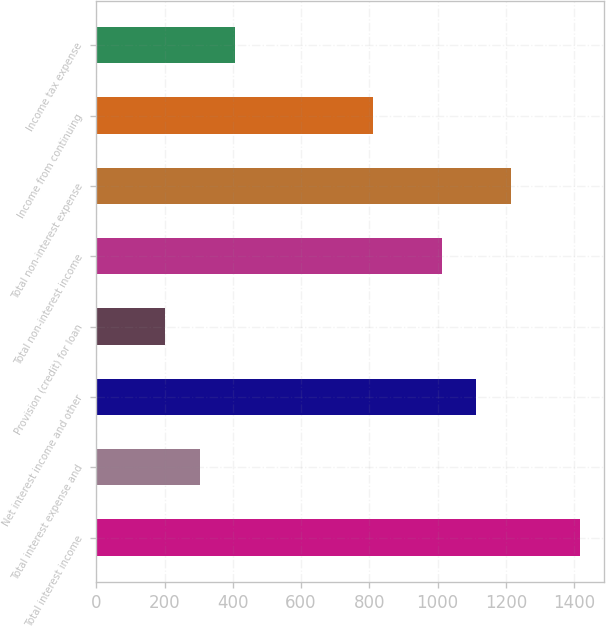Convert chart. <chart><loc_0><loc_0><loc_500><loc_500><bar_chart><fcel>Total interest income<fcel>Total interest expense and<fcel>Net interest income and other<fcel>Provision (credit) for loan<fcel>Total non-interest income<fcel>Total non-interest expense<fcel>Income from continuing<fcel>Income tax expense<nl><fcel>1416.73<fcel>303.79<fcel>1113.21<fcel>202.61<fcel>1012.04<fcel>1214.38<fcel>809.68<fcel>404.97<nl></chart> 